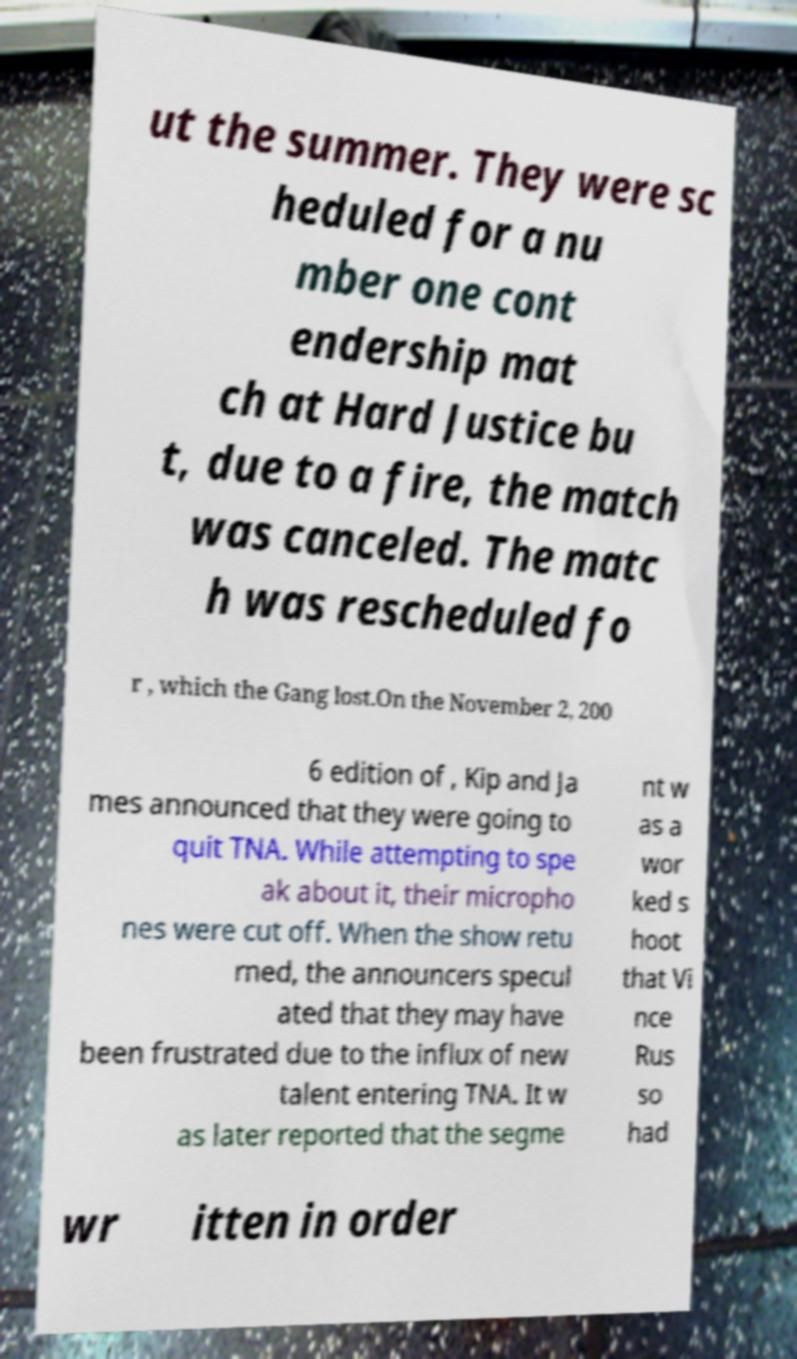Can you read and provide the text displayed in the image?This photo seems to have some interesting text. Can you extract and type it out for me? ut the summer. They were sc heduled for a nu mber one cont endership mat ch at Hard Justice bu t, due to a fire, the match was canceled. The matc h was rescheduled fo r , which the Gang lost.On the November 2, 200 6 edition of , Kip and Ja mes announced that they were going to quit TNA. While attempting to spe ak about it, their micropho nes were cut off. When the show retu rned, the announcers specul ated that they may have been frustrated due to the influx of new talent entering TNA. It w as later reported that the segme nt w as a wor ked s hoot that Vi nce Rus so had wr itten in order 